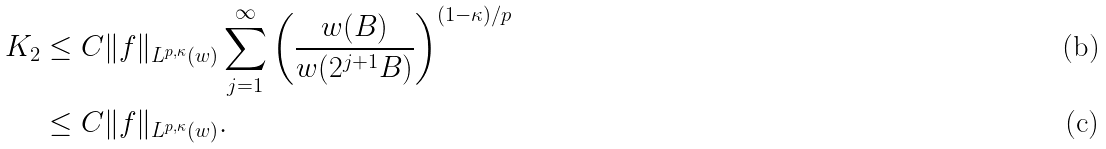<formula> <loc_0><loc_0><loc_500><loc_500>K _ { 2 } & \leq C \| f \| _ { L ^ { p , \kappa } ( w ) } \sum _ { j = 1 } ^ { \infty } \left ( \frac { w ( B ) } { w ( 2 ^ { j + 1 } B ) } \right ) ^ { ( 1 - \kappa ) / p } \\ & \leq C \| f \| _ { L ^ { p , \kappa } ( w ) } .</formula> 